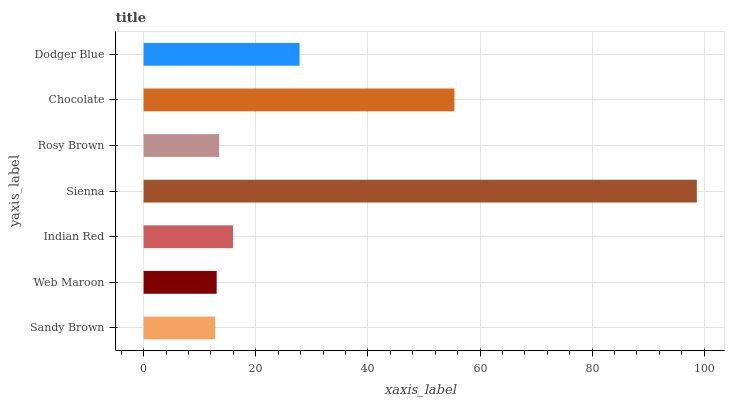Is Sandy Brown the minimum?
Answer yes or no. Yes. Is Sienna the maximum?
Answer yes or no. Yes. Is Web Maroon the minimum?
Answer yes or no. No. Is Web Maroon the maximum?
Answer yes or no. No. Is Web Maroon greater than Sandy Brown?
Answer yes or no. Yes. Is Sandy Brown less than Web Maroon?
Answer yes or no. Yes. Is Sandy Brown greater than Web Maroon?
Answer yes or no. No. Is Web Maroon less than Sandy Brown?
Answer yes or no. No. Is Indian Red the high median?
Answer yes or no. Yes. Is Indian Red the low median?
Answer yes or no. Yes. Is Web Maroon the high median?
Answer yes or no. No. Is Rosy Brown the low median?
Answer yes or no. No. 